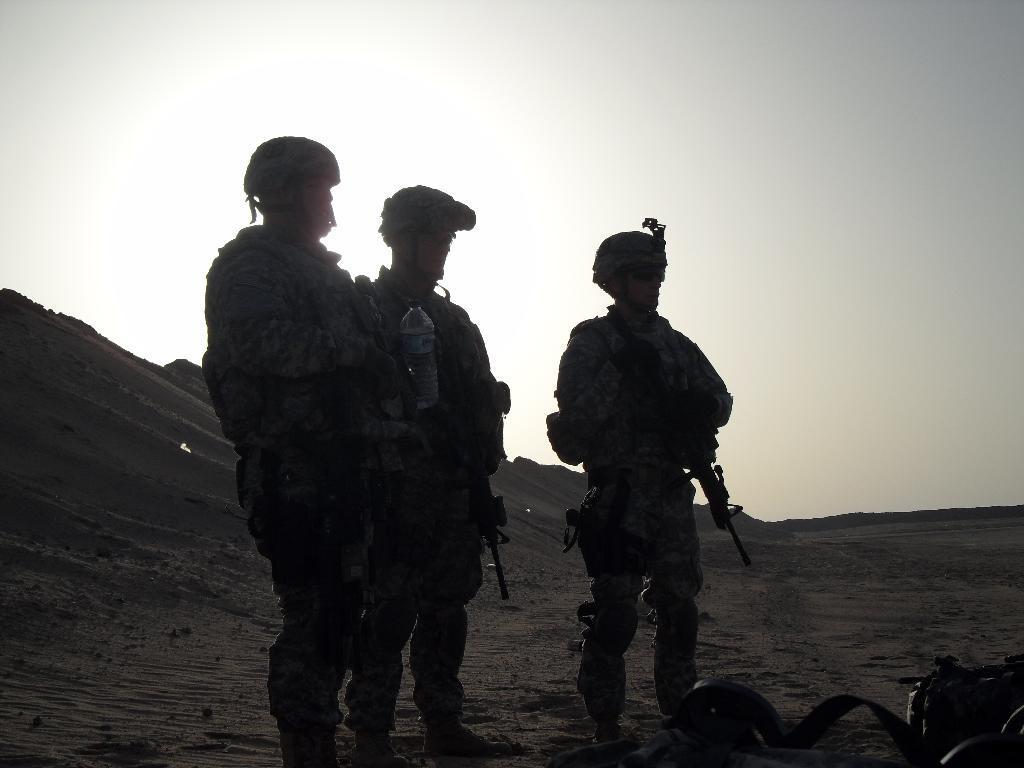Describe this image in one or two sentences. In this picture, we see three men in the uniform are standing. They are holding the rifles in their hands. The man on the left side is holding a water bottle in his hand. At the bottom, we see the sand. In the right bottom, we see an object in black color. In the background, we see the sand heaps. At the top, we see the sky. It is a sunny day. 